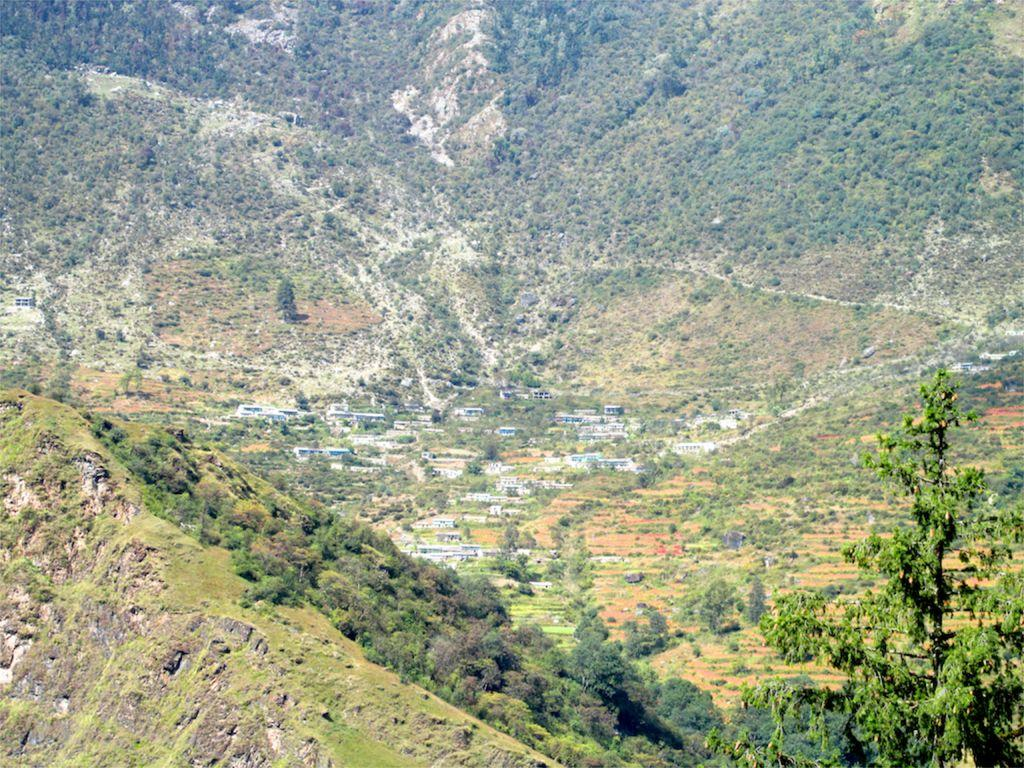What type of natural landscape can be seen in the image? There are hills in the image. What type of vegetation is present in the image? There are trees in the image. What type of bubble is floating near the trees in the image? There is no bubble present in the image; it only features hills and trees. How many accounts are visible in the image? There are no accounts present in the image, as it only contains natural elements such as hills and trees. 